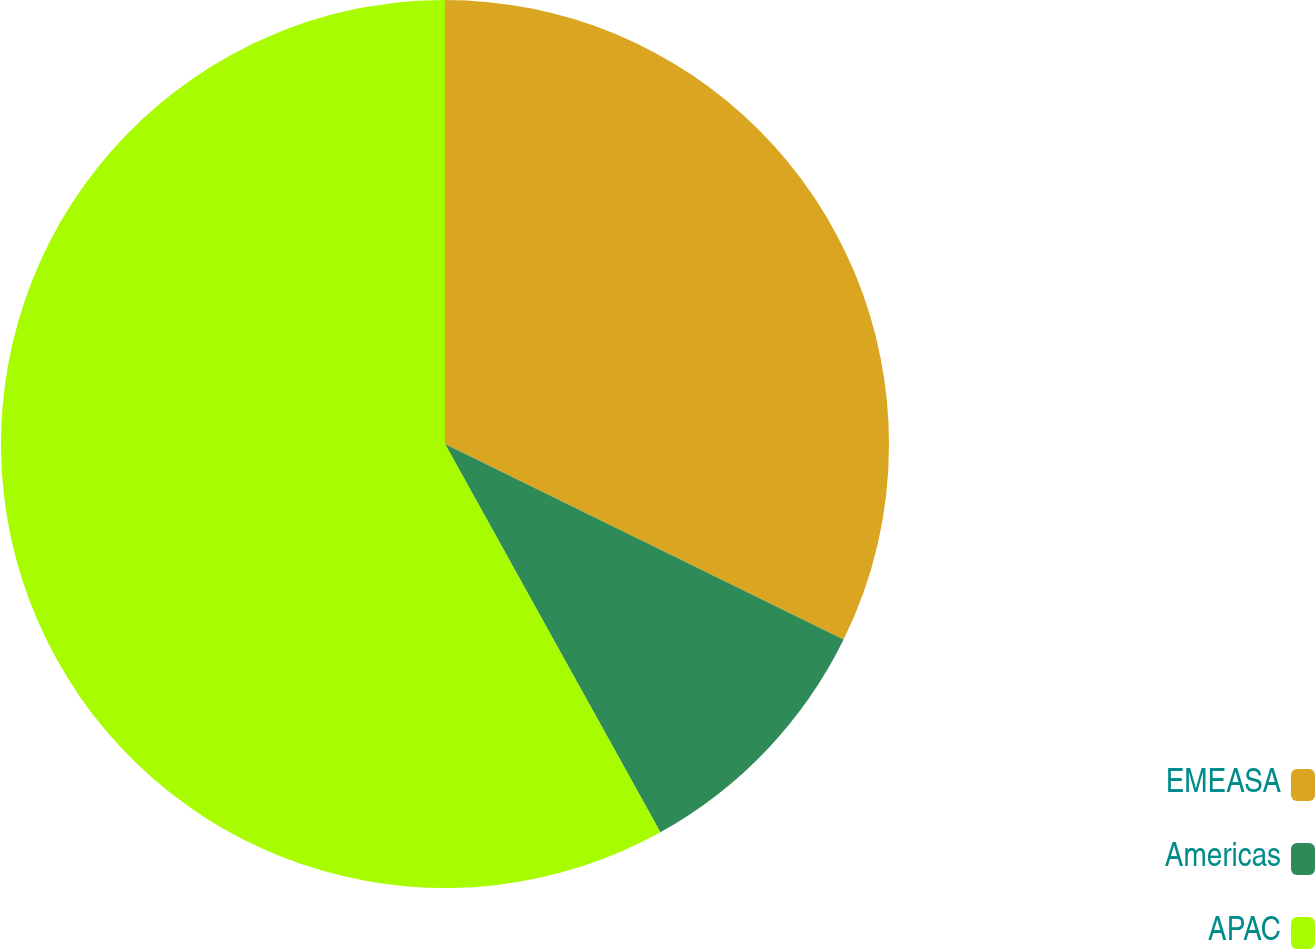<chart> <loc_0><loc_0><loc_500><loc_500><pie_chart><fcel>EMEASA<fcel>Americas<fcel>APAC<nl><fcel>32.26%<fcel>9.68%<fcel>58.06%<nl></chart> 